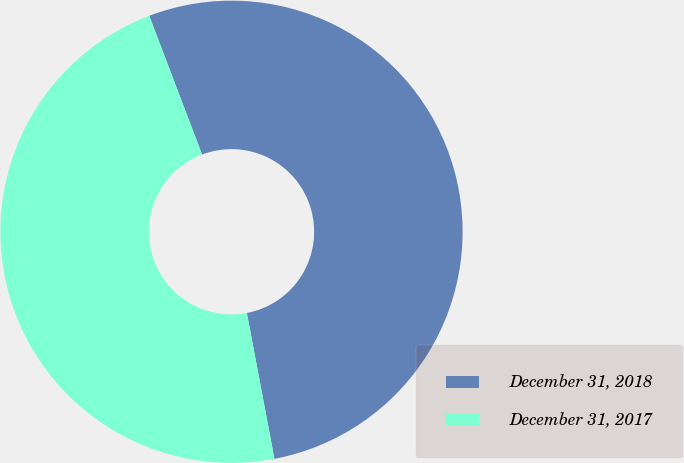Convert chart to OTSL. <chart><loc_0><loc_0><loc_500><loc_500><pie_chart><fcel>December 31, 2018<fcel>December 31, 2017<nl><fcel>52.82%<fcel>47.18%<nl></chart> 